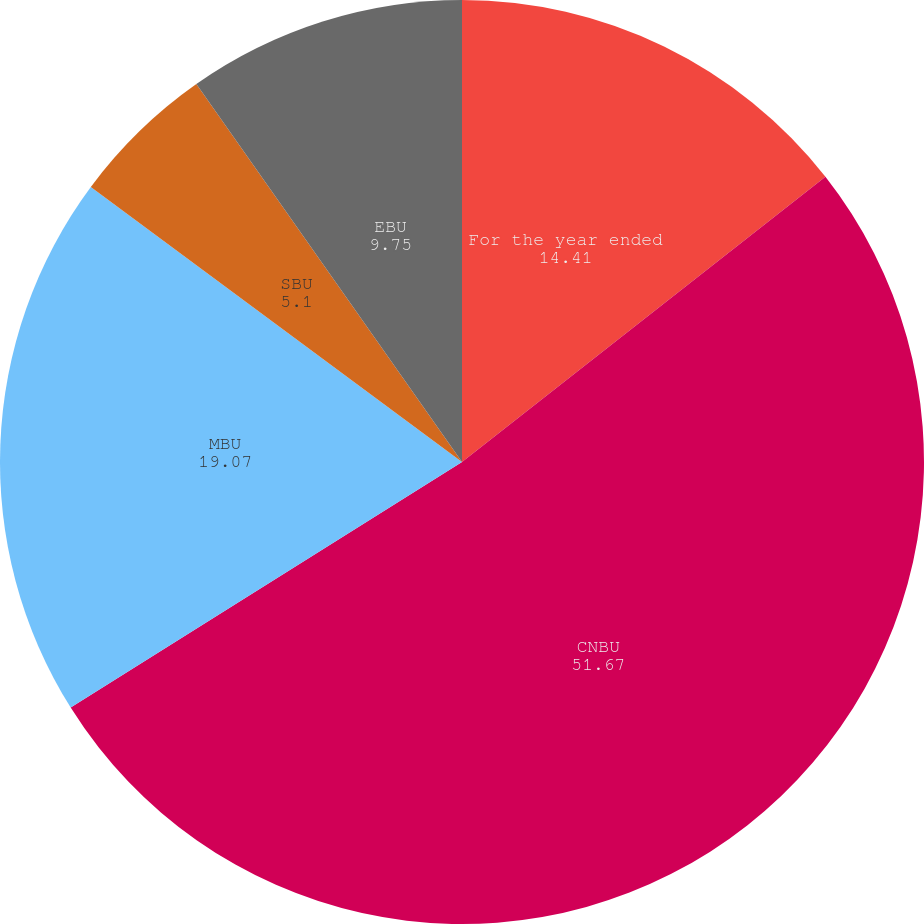<chart> <loc_0><loc_0><loc_500><loc_500><pie_chart><fcel>For the year ended<fcel>CNBU<fcel>MBU<fcel>SBU<fcel>EBU<nl><fcel>14.41%<fcel>51.67%<fcel>19.07%<fcel>5.1%<fcel>9.75%<nl></chart> 